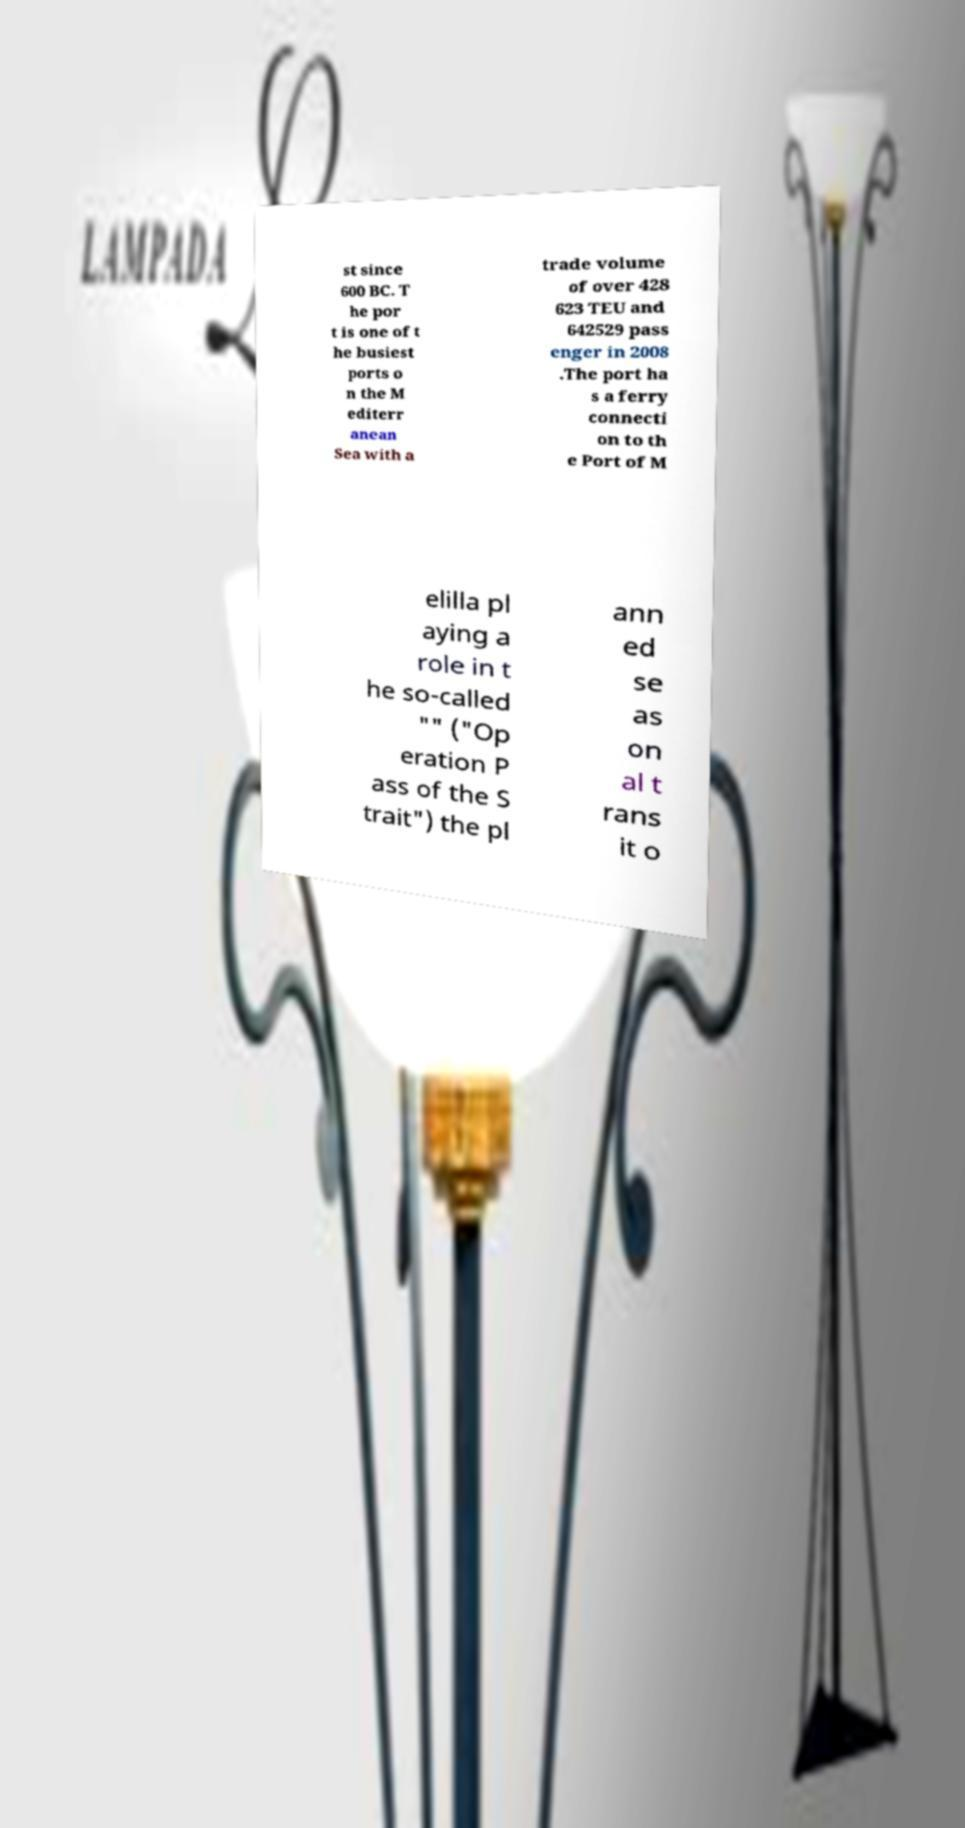I need the written content from this picture converted into text. Can you do that? st since 600 BC. T he por t is one of t he busiest ports o n the M editerr anean Sea with a trade volume of over 428 623 TEU and 642529 pass enger in 2008 .The port ha s a ferry connecti on to th e Port of M elilla pl aying a role in t he so-called "" ("Op eration P ass of the S trait") the pl ann ed se as on al t rans it o 